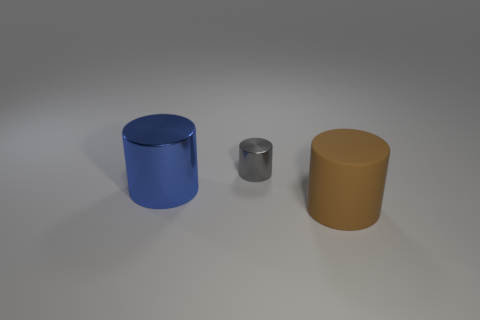Is there anything else that is the same size as the gray thing?
Provide a succinct answer. No. There is a big cylinder that is behind the large matte cylinder; is it the same color as the shiny cylinder behind the blue metallic cylinder?
Your response must be concise. No. What number of big blue cylinders are behind the brown matte cylinder?
Your response must be concise. 1. Are there any purple rubber things that have the same shape as the tiny metallic object?
Provide a succinct answer. No. Are the large cylinder that is on the left side of the tiny cylinder and the cylinder behind the blue metal cylinder made of the same material?
Provide a succinct answer. Yes. There is a shiny cylinder that is behind the big cylinder that is left of the big object that is in front of the large blue metal thing; how big is it?
Make the answer very short. Small. What material is the other object that is the same size as the blue shiny thing?
Your response must be concise. Rubber. Are there any shiny objects that have the same size as the matte cylinder?
Your response must be concise. Yes. Is the brown rubber thing the same shape as the small gray shiny thing?
Provide a succinct answer. Yes. Is there a thing on the left side of the big thing on the left side of the cylinder in front of the blue cylinder?
Offer a very short reply. No. 